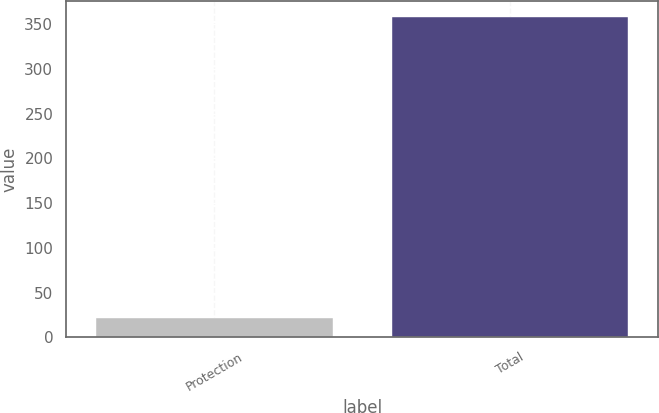Convert chart. <chart><loc_0><loc_0><loc_500><loc_500><bar_chart><fcel>Protection<fcel>Total<nl><fcel>22<fcel>358<nl></chart> 